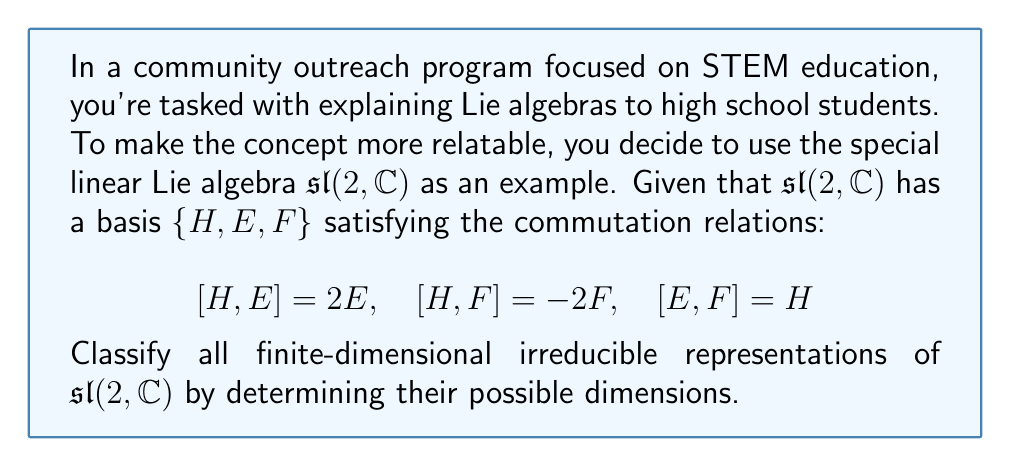Can you answer this question? To classify the irreducible representations of $\mathfrak{sl}(2, \mathbb{C})$, we'll follow these steps:

1) First, recall that for any finite-dimensional irreducible representation of $\mathfrak{sl}(2, \mathbb{C})$, there exists a basis of weight vectors.

2) Let $V$ be an irreducible representation. The element $H$ acts diagonally on $V$, and its eigenvalues are called weights.

3) The highest weight theorem states that there is a unique (up to scalar multiple) highest weight vector $v_\lambda$ such that:

   $Hv_\lambda = \lambda v_\lambda$ and $Ev_\lambda = 0$

   where $\lambda$ is the highest weight.

4) Starting from $v_\lambda$, we can generate other weight vectors by repeatedly applying $F$:

   $v_{\lambda-2}, v_{\lambda-4}, ..., v_{\lambda-2k}, ...$

   until we reach a vector $v_{\lambda-2n}$ such that $Fv_{\lambda-2n} = 0$.

5) This process gives us a basis for $V$:

   $\{v_\lambda, v_{\lambda-2}, ..., v_{\lambda-2n}\}$

6) The dimension of $V$ is therefore $n+1$.

7) To ensure that this is a valid representation, we must have $\lambda \in \mathbb{Z}_{\geq 0}$ (non-negative integer).

8) The dimension of the representation is then $\lambda + 1$.

Therefore, for each non-negative integer $\lambda$, there exists a unique (up to isomorphism) irreducible representation of $\mathfrak{sl}(2, \mathbb{C})$ with dimension $\lambda + 1$.
Answer: The irreducible representations of $\mathfrak{sl}(2, \mathbb{C})$ are classified by their dimensions, which are all positive integers. For each $n \in \mathbb{Z}_{> 0}$, there exists a unique $n$-dimensional irreducible representation of $\mathfrak{sl}(2, \mathbb{C})$. 